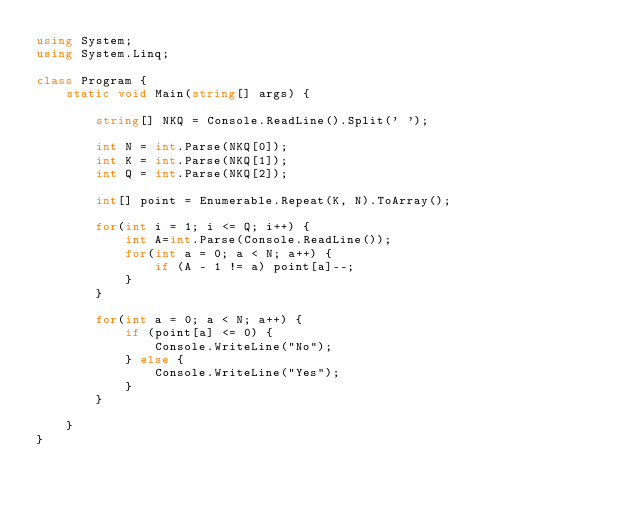<code> <loc_0><loc_0><loc_500><loc_500><_C#_>using System;
using System.Linq;

class Program {
    static void Main(string[] args) {

        string[] NKQ = Console.ReadLine().Split(' ');

        int N = int.Parse(NKQ[0]);
        int K = int.Parse(NKQ[1]);
        int Q = int.Parse(NKQ[2]);

        int[] point = Enumerable.Repeat(K, N).ToArray();

        for(int i = 1; i <= Q; i++) {
            int A=int.Parse(Console.ReadLine());
            for(int a = 0; a < N; a++) {
                if (A - 1 != a) point[a]--;
            }
        }

        for(int a = 0; a < N; a++) {
            if (point[a] <= 0) {
                Console.WriteLine("No");
            } else {
                Console.WriteLine("Yes");
            }
        }

    }
}</code> 